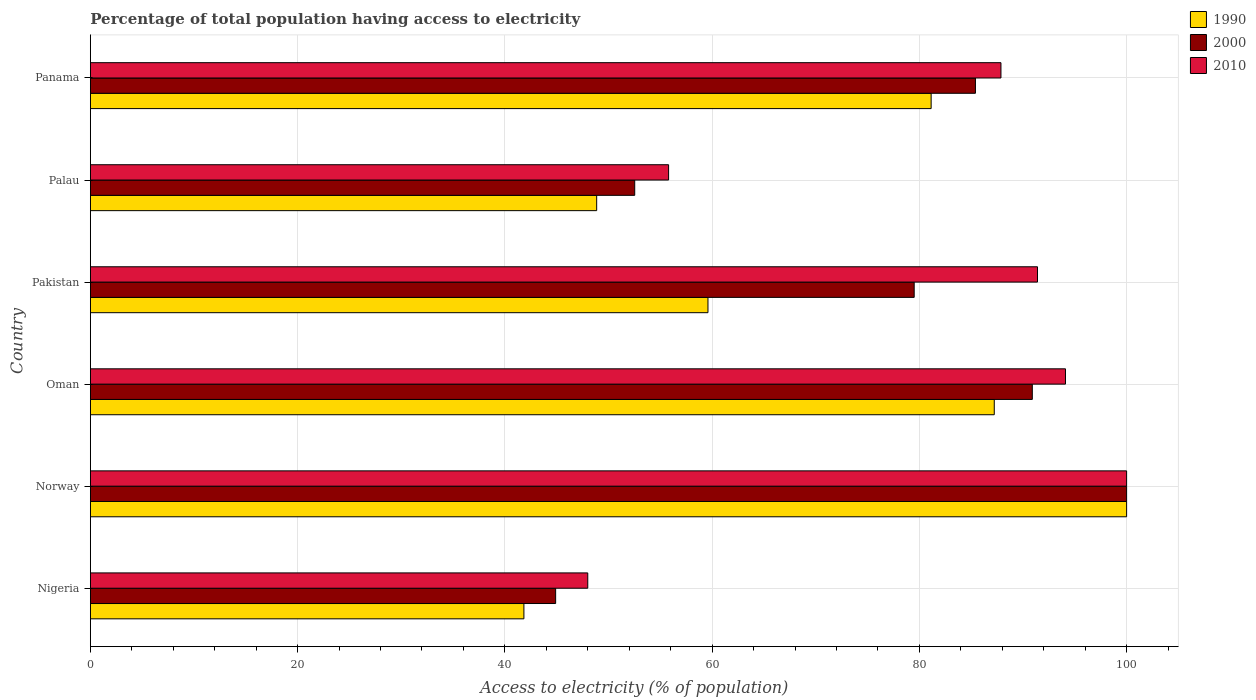How many groups of bars are there?
Give a very brief answer. 6. What is the label of the 5th group of bars from the top?
Your answer should be compact. Norway. What is the percentage of population that have access to electricity in 1990 in Panama?
Ensure brevity in your answer.  81.14. Across all countries, what is the maximum percentage of population that have access to electricity in 2000?
Make the answer very short. 100. Across all countries, what is the minimum percentage of population that have access to electricity in 2010?
Ensure brevity in your answer.  48. In which country was the percentage of population that have access to electricity in 2000 minimum?
Ensure brevity in your answer.  Nigeria. What is the total percentage of population that have access to electricity in 1990 in the graph?
Offer a terse response. 418.66. What is the difference between the percentage of population that have access to electricity in 1990 in Nigeria and that in Norway?
Offer a terse response. -58.16. What is the difference between the percentage of population that have access to electricity in 1990 in Panama and the percentage of population that have access to electricity in 2000 in Pakistan?
Your response must be concise. 1.64. What is the average percentage of population that have access to electricity in 1990 per country?
Your answer should be very brief. 69.78. What is the difference between the percentage of population that have access to electricity in 1990 and percentage of population that have access to electricity in 2010 in Nigeria?
Keep it short and to the point. -6.16. In how many countries, is the percentage of population that have access to electricity in 1990 greater than 96 %?
Make the answer very short. 1. What is the ratio of the percentage of population that have access to electricity in 2000 in Nigeria to that in Pakistan?
Provide a short and direct response. 0.56. Is the percentage of population that have access to electricity in 2000 in Nigeria less than that in Norway?
Ensure brevity in your answer.  Yes. What is the difference between the highest and the second highest percentage of population that have access to electricity in 1990?
Offer a very short reply. 12.77. In how many countries, is the percentage of population that have access to electricity in 2010 greater than the average percentage of population that have access to electricity in 2010 taken over all countries?
Your answer should be compact. 4. Is it the case that in every country, the sum of the percentage of population that have access to electricity in 2000 and percentage of population that have access to electricity in 1990 is greater than the percentage of population that have access to electricity in 2010?
Provide a succinct answer. Yes. How many bars are there?
Give a very brief answer. 18. What is the difference between two consecutive major ticks on the X-axis?
Provide a succinct answer. 20. Are the values on the major ticks of X-axis written in scientific E-notation?
Your answer should be very brief. No. Does the graph contain grids?
Provide a short and direct response. Yes. Where does the legend appear in the graph?
Ensure brevity in your answer.  Top right. How many legend labels are there?
Make the answer very short. 3. What is the title of the graph?
Provide a short and direct response. Percentage of total population having access to electricity. What is the label or title of the X-axis?
Provide a short and direct response. Access to electricity (% of population). What is the Access to electricity (% of population) in 1990 in Nigeria?
Your answer should be compact. 41.84. What is the Access to electricity (% of population) in 2000 in Nigeria?
Provide a short and direct response. 44.9. What is the Access to electricity (% of population) in 1990 in Norway?
Your response must be concise. 100. What is the Access to electricity (% of population) in 2010 in Norway?
Your answer should be compact. 100. What is the Access to electricity (% of population) of 1990 in Oman?
Your response must be concise. 87.23. What is the Access to electricity (% of population) in 2000 in Oman?
Your answer should be very brief. 90.9. What is the Access to electricity (% of population) of 2010 in Oman?
Make the answer very short. 94.1. What is the Access to electricity (% of population) of 1990 in Pakistan?
Ensure brevity in your answer.  59.6. What is the Access to electricity (% of population) of 2000 in Pakistan?
Provide a succinct answer. 79.5. What is the Access to electricity (% of population) of 2010 in Pakistan?
Provide a short and direct response. 91.4. What is the Access to electricity (% of population) in 1990 in Palau?
Give a very brief answer. 48.86. What is the Access to electricity (% of population) of 2000 in Palau?
Make the answer very short. 52.53. What is the Access to electricity (% of population) of 2010 in Palau?
Provide a short and direct response. 55.8. What is the Access to electricity (% of population) of 1990 in Panama?
Your response must be concise. 81.14. What is the Access to electricity (% of population) in 2000 in Panama?
Offer a terse response. 85.41. What is the Access to electricity (% of population) in 2010 in Panama?
Your answer should be very brief. 87.87. Across all countries, what is the maximum Access to electricity (% of population) of 1990?
Offer a terse response. 100. Across all countries, what is the maximum Access to electricity (% of population) of 2000?
Offer a very short reply. 100. Across all countries, what is the maximum Access to electricity (% of population) of 2010?
Ensure brevity in your answer.  100. Across all countries, what is the minimum Access to electricity (% of population) of 1990?
Offer a very short reply. 41.84. Across all countries, what is the minimum Access to electricity (% of population) in 2000?
Your answer should be very brief. 44.9. What is the total Access to electricity (% of population) of 1990 in the graph?
Keep it short and to the point. 418.66. What is the total Access to electricity (% of population) of 2000 in the graph?
Your response must be concise. 453.24. What is the total Access to electricity (% of population) of 2010 in the graph?
Provide a succinct answer. 477.17. What is the difference between the Access to electricity (% of population) in 1990 in Nigeria and that in Norway?
Keep it short and to the point. -58.16. What is the difference between the Access to electricity (% of population) in 2000 in Nigeria and that in Norway?
Provide a short and direct response. -55.1. What is the difference between the Access to electricity (% of population) of 2010 in Nigeria and that in Norway?
Keep it short and to the point. -52. What is the difference between the Access to electricity (% of population) in 1990 in Nigeria and that in Oman?
Offer a terse response. -45.39. What is the difference between the Access to electricity (% of population) in 2000 in Nigeria and that in Oman?
Make the answer very short. -46. What is the difference between the Access to electricity (% of population) in 2010 in Nigeria and that in Oman?
Provide a succinct answer. -46.1. What is the difference between the Access to electricity (% of population) of 1990 in Nigeria and that in Pakistan?
Keep it short and to the point. -17.76. What is the difference between the Access to electricity (% of population) of 2000 in Nigeria and that in Pakistan?
Your response must be concise. -34.6. What is the difference between the Access to electricity (% of population) of 2010 in Nigeria and that in Pakistan?
Provide a succinct answer. -43.4. What is the difference between the Access to electricity (% of population) of 1990 in Nigeria and that in Palau?
Your answer should be very brief. -7.02. What is the difference between the Access to electricity (% of population) of 2000 in Nigeria and that in Palau?
Your response must be concise. -7.63. What is the difference between the Access to electricity (% of population) in 2010 in Nigeria and that in Palau?
Keep it short and to the point. -7.8. What is the difference between the Access to electricity (% of population) of 1990 in Nigeria and that in Panama?
Offer a terse response. -39.3. What is the difference between the Access to electricity (% of population) of 2000 in Nigeria and that in Panama?
Give a very brief answer. -40.51. What is the difference between the Access to electricity (% of population) in 2010 in Nigeria and that in Panama?
Keep it short and to the point. -39.87. What is the difference between the Access to electricity (% of population) in 1990 in Norway and that in Oman?
Provide a succinct answer. 12.77. What is the difference between the Access to electricity (% of population) of 2000 in Norway and that in Oman?
Your answer should be compact. 9.1. What is the difference between the Access to electricity (% of population) of 2010 in Norway and that in Oman?
Keep it short and to the point. 5.9. What is the difference between the Access to electricity (% of population) of 1990 in Norway and that in Pakistan?
Ensure brevity in your answer.  40.4. What is the difference between the Access to electricity (% of population) of 2000 in Norway and that in Pakistan?
Provide a short and direct response. 20.5. What is the difference between the Access to electricity (% of population) in 2010 in Norway and that in Pakistan?
Provide a succinct answer. 8.6. What is the difference between the Access to electricity (% of population) of 1990 in Norway and that in Palau?
Provide a succinct answer. 51.14. What is the difference between the Access to electricity (% of population) of 2000 in Norway and that in Palau?
Make the answer very short. 47.47. What is the difference between the Access to electricity (% of population) of 2010 in Norway and that in Palau?
Keep it short and to the point. 44.2. What is the difference between the Access to electricity (% of population) in 1990 in Norway and that in Panama?
Provide a short and direct response. 18.86. What is the difference between the Access to electricity (% of population) in 2000 in Norway and that in Panama?
Give a very brief answer. 14.59. What is the difference between the Access to electricity (% of population) of 2010 in Norway and that in Panama?
Give a very brief answer. 12.13. What is the difference between the Access to electricity (% of population) in 1990 in Oman and that in Pakistan?
Your answer should be very brief. 27.63. What is the difference between the Access to electricity (% of population) of 2000 in Oman and that in Pakistan?
Provide a short and direct response. 11.4. What is the difference between the Access to electricity (% of population) in 2010 in Oman and that in Pakistan?
Make the answer very short. 2.7. What is the difference between the Access to electricity (% of population) of 1990 in Oman and that in Palau?
Provide a succinct answer. 38.37. What is the difference between the Access to electricity (% of population) in 2000 in Oman and that in Palau?
Your answer should be very brief. 38.37. What is the difference between the Access to electricity (% of population) in 2010 in Oman and that in Palau?
Provide a succinct answer. 38.3. What is the difference between the Access to electricity (% of population) of 1990 in Oman and that in Panama?
Make the answer very short. 6.09. What is the difference between the Access to electricity (% of population) of 2000 in Oman and that in Panama?
Offer a terse response. 5.49. What is the difference between the Access to electricity (% of population) in 2010 in Oman and that in Panama?
Keep it short and to the point. 6.23. What is the difference between the Access to electricity (% of population) of 1990 in Pakistan and that in Palau?
Ensure brevity in your answer.  10.74. What is the difference between the Access to electricity (% of population) in 2000 in Pakistan and that in Palau?
Offer a terse response. 26.97. What is the difference between the Access to electricity (% of population) in 2010 in Pakistan and that in Palau?
Make the answer very short. 35.6. What is the difference between the Access to electricity (% of population) in 1990 in Pakistan and that in Panama?
Give a very brief answer. -21.54. What is the difference between the Access to electricity (% of population) in 2000 in Pakistan and that in Panama?
Your answer should be compact. -5.91. What is the difference between the Access to electricity (% of population) in 2010 in Pakistan and that in Panama?
Offer a terse response. 3.53. What is the difference between the Access to electricity (% of population) of 1990 in Palau and that in Panama?
Your response must be concise. -32.28. What is the difference between the Access to electricity (% of population) of 2000 in Palau and that in Panama?
Your answer should be very brief. -32.88. What is the difference between the Access to electricity (% of population) of 2010 in Palau and that in Panama?
Provide a short and direct response. -32.07. What is the difference between the Access to electricity (% of population) in 1990 in Nigeria and the Access to electricity (% of population) in 2000 in Norway?
Your answer should be very brief. -58.16. What is the difference between the Access to electricity (% of population) of 1990 in Nigeria and the Access to electricity (% of population) of 2010 in Norway?
Your response must be concise. -58.16. What is the difference between the Access to electricity (% of population) in 2000 in Nigeria and the Access to electricity (% of population) in 2010 in Norway?
Ensure brevity in your answer.  -55.1. What is the difference between the Access to electricity (% of population) of 1990 in Nigeria and the Access to electricity (% of population) of 2000 in Oman?
Make the answer very short. -49.06. What is the difference between the Access to electricity (% of population) in 1990 in Nigeria and the Access to electricity (% of population) in 2010 in Oman?
Provide a succinct answer. -52.26. What is the difference between the Access to electricity (% of population) of 2000 in Nigeria and the Access to electricity (% of population) of 2010 in Oman?
Keep it short and to the point. -49.2. What is the difference between the Access to electricity (% of population) in 1990 in Nigeria and the Access to electricity (% of population) in 2000 in Pakistan?
Make the answer very short. -37.66. What is the difference between the Access to electricity (% of population) of 1990 in Nigeria and the Access to electricity (% of population) of 2010 in Pakistan?
Keep it short and to the point. -49.56. What is the difference between the Access to electricity (% of population) in 2000 in Nigeria and the Access to electricity (% of population) in 2010 in Pakistan?
Offer a terse response. -46.5. What is the difference between the Access to electricity (% of population) in 1990 in Nigeria and the Access to electricity (% of population) in 2000 in Palau?
Offer a very short reply. -10.69. What is the difference between the Access to electricity (% of population) in 1990 in Nigeria and the Access to electricity (% of population) in 2010 in Palau?
Your answer should be compact. -13.96. What is the difference between the Access to electricity (% of population) in 1990 in Nigeria and the Access to electricity (% of population) in 2000 in Panama?
Make the answer very short. -43.57. What is the difference between the Access to electricity (% of population) in 1990 in Nigeria and the Access to electricity (% of population) in 2010 in Panama?
Give a very brief answer. -46.04. What is the difference between the Access to electricity (% of population) of 2000 in Nigeria and the Access to electricity (% of population) of 2010 in Panama?
Make the answer very short. -42.97. What is the difference between the Access to electricity (% of population) in 1990 in Norway and the Access to electricity (% of population) in 2000 in Oman?
Offer a very short reply. 9.1. What is the difference between the Access to electricity (% of population) of 1990 in Norway and the Access to electricity (% of population) of 2010 in Oman?
Ensure brevity in your answer.  5.9. What is the difference between the Access to electricity (% of population) in 1990 in Norway and the Access to electricity (% of population) in 2000 in Pakistan?
Make the answer very short. 20.5. What is the difference between the Access to electricity (% of population) of 2000 in Norway and the Access to electricity (% of population) of 2010 in Pakistan?
Make the answer very short. 8.6. What is the difference between the Access to electricity (% of population) in 1990 in Norway and the Access to electricity (% of population) in 2000 in Palau?
Ensure brevity in your answer.  47.47. What is the difference between the Access to electricity (% of population) in 1990 in Norway and the Access to electricity (% of population) in 2010 in Palau?
Offer a very short reply. 44.2. What is the difference between the Access to electricity (% of population) in 2000 in Norway and the Access to electricity (% of population) in 2010 in Palau?
Your answer should be very brief. 44.2. What is the difference between the Access to electricity (% of population) in 1990 in Norway and the Access to electricity (% of population) in 2000 in Panama?
Provide a short and direct response. 14.59. What is the difference between the Access to electricity (% of population) of 1990 in Norway and the Access to electricity (% of population) of 2010 in Panama?
Offer a terse response. 12.13. What is the difference between the Access to electricity (% of population) of 2000 in Norway and the Access to electricity (% of population) of 2010 in Panama?
Ensure brevity in your answer.  12.13. What is the difference between the Access to electricity (% of population) in 1990 in Oman and the Access to electricity (% of population) in 2000 in Pakistan?
Your response must be concise. 7.73. What is the difference between the Access to electricity (% of population) in 1990 in Oman and the Access to electricity (% of population) in 2010 in Pakistan?
Ensure brevity in your answer.  -4.17. What is the difference between the Access to electricity (% of population) in 2000 in Oman and the Access to electricity (% of population) in 2010 in Pakistan?
Offer a terse response. -0.5. What is the difference between the Access to electricity (% of population) of 1990 in Oman and the Access to electricity (% of population) of 2000 in Palau?
Your answer should be compact. 34.7. What is the difference between the Access to electricity (% of population) of 1990 in Oman and the Access to electricity (% of population) of 2010 in Palau?
Provide a short and direct response. 31.43. What is the difference between the Access to electricity (% of population) of 2000 in Oman and the Access to electricity (% of population) of 2010 in Palau?
Your answer should be very brief. 35.1. What is the difference between the Access to electricity (% of population) of 1990 in Oman and the Access to electricity (% of population) of 2000 in Panama?
Ensure brevity in your answer.  1.82. What is the difference between the Access to electricity (% of population) of 1990 in Oman and the Access to electricity (% of population) of 2010 in Panama?
Your answer should be compact. -0.65. What is the difference between the Access to electricity (% of population) in 2000 in Oman and the Access to electricity (% of population) in 2010 in Panama?
Keep it short and to the point. 3.03. What is the difference between the Access to electricity (% of population) in 1990 in Pakistan and the Access to electricity (% of population) in 2000 in Palau?
Keep it short and to the point. 7.07. What is the difference between the Access to electricity (% of population) in 2000 in Pakistan and the Access to electricity (% of population) in 2010 in Palau?
Offer a very short reply. 23.7. What is the difference between the Access to electricity (% of population) of 1990 in Pakistan and the Access to electricity (% of population) of 2000 in Panama?
Provide a short and direct response. -25.81. What is the difference between the Access to electricity (% of population) in 1990 in Pakistan and the Access to electricity (% of population) in 2010 in Panama?
Your response must be concise. -28.27. What is the difference between the Access to electricity (% of population) of 2000 in Pakistan and the Access to electricity (% of population) of 2010 in Panama?
Offer a very short reply. -8.37. What is the difference between the Access to electricity (% of population) of 1990 in Palau and the Access to electricity (% of population) of 2000 in Panama?
Your answer should be compact. -36.55. What is the difference between the Access to electricity (% of population) in 1990 in Palau and the Access to electricity (% of population) in 2010 in Panama?
Provide a short and direct response. -39.01. What is the difference between the Access to electricity (% of population) of 2000 in Palau and the Access to electricity (% of population) of 2010 in Panama?
Make the answer very short. -35.34. What is the average Access to electricity (% of population) in 1990 per country?
Your answer should be very brief. 69.78. What is the average Access to electricity (% of population) in 2000 per country?
Offer a terse response. 75.54. What is the average Access to electricity (% of population) of 2010 per country?
Your answer should be very brief. 79.53. What is the difference between the Access to electricity (% of population) of 1990 and Access to electricity (% of population) of 2000 in Nigeria?
Give a very brief answer. -3.06. What is the difference between the Access to electricity (% of population) of 1990 and Access to electricity (% of population) of 2010 in Nigeria?
Keep it short and to the point. -6.16. What is the difference between the Access to electricity (% of population) in 2000 and Access to electricity (% of population) in 2010 in Nigeria?
Your answer should be compact. -3.1. What is the difference between the Access to electricity (% of population) in 1990 and Access to electricity (% of population) in 2000 in Norway?
Provide a succinct answer. 0. What is the difference between the Access to electricity (% of population) of 2000 and Access to electricity (% of population) of 2010 in Norway?
Ensure brevity in your answer.  0. What is the difference between the Access to electricity (% of population) of 1990 and Access to electricity (% of population) of 2000 in Oman?
Your answer should be compact. -3.67. What is the difference between the Access to electricity (% of population) in 1990 and Access to electricity (% of population) in 2010 in Oman?
Offer a terse response. -6.87. What is the difference between the Access to electricity (% of population) in 2000 and Access to electricity (% of population) in 2010 in Oman?
Provide a short and direct response. -3.2. What is the difference between the Access to electricity (% of population) of 1990 and Access to electricity (% of population) of 2000 in Pakistan?
Make the answer very short. -19.9. What is the difference between the Access to electricity (% of population) in 1990 and Access to electricity (% of population) in 2010 in Pakistan?
Offer a terse response. -31.8. What is the difference between the Access to electricity (% of population) in 2000 and Access to electricity (% of population) in 2010 in Pakistan?
Offer a very short reply. -11.9. What is the difference between the Access to electricity (% of population) of 1990 and Access to electricity (% of population) of 2000 in Palau?
Give a very brief answer. -3.67. What is the difference between the Access to electricity (% of population) in 1990 and Access to electricity (% of population) in 2010 in Palau?
Provide a short and direct response. -6.94. What is the difference between the Access to electricity (% of population) in 2000 and Access to electricity (% of population) in 2010 in Palau?
Offer a terse response. -3.27. What is the difference between the Access to electricity (% of population) in 1990 and Access to electricity (% of population) in 2000 in Panama?
Your response must be concise. -4.28. What is the difference between the Access to electricity (% of population) of 1990 and Access to electricity (% of population) of 2010 in Panama?
Keep it short and to the point. -6.74. What is the difference between the Access to electricity (% of population) in 2000 and Access to electricity (% of population) in 2010 in Panama?
Provide a short and direct response. -2.46. What is the ratio of the Access to electricity (% of population) in 1990 in Nigeria to that in Norway?
Your answer should be compact. 0.42. What is the ratio of the Access to electricity (% of population) in 2000 in Nigeria to that in Norway?
Ensure brevity in your answer.  0.45. What is the ratio of the Access to electricity (% of population) in 2010 in Nigeria to that in Norway?
Ensure brevity in your answer.  0.48. What is the ratio of the Access to electricity (% of population) of 1990 in Nigeria to that in Oman?
Give a very brief answer. 0.48. What is the ratio of the Access to electricity (% of population) of 2000 in Nigeria to that in Oman?
Ensure brevity in your answer.  0.49. What is the ratio of the Access to electricity (% of population) in 2010 in Nigeria to that in Oman?
Your answer should be very brief. 0.51. What is the ratio of the Access to electricity (% of population) in 1990 in Nigeria to that in Pakistan?
Provide a succinct answer. 0.7. What is the ratio of the Access to electricity (% of population) of 2000 in Nigeria to that in Pakistan?
Provide a succinct answer. 0.56. What is the ratio of the Access to electricity (% of population) of 2010 in Nigeria to that in Pakistan?
Your response must be concise. 0.53. What is the ratio of the Access to electricity (% of population) of 1990 in Nigeria to that in Palau?
Ensure brevity in your answer.  0.86. What is the ratio of the Access to electricity (% of population) in 2000 in Nigeria to that in Palau?
Your answer should be very brief. 0.85. What is the ratio of the Access to electricity (% of population) of 2010 in Nigeria to that in Palau?
Give a very brief answer. 0.86. What is the ratio of the Access to electricity (% of population) in 1990 in Nigeria to that in Panama?
Keep it short and to the point. 0.52. What is the ratio of the Access to electricity (% of population) of 2000 in Nigeria to that in Panama?
Provide a succinct answer. 0.53. What is the ratio of the Access to electricity (% of population) of 2010 in Nigeria to that in Panama?
Offer a terse response. 0.55. What is the ratio of the Access to electricity (% of population) in 1990 in Norway to that in Oman?
Keep it short and to the point. 1.15. What is the ratio of the Access to electricity (% of population) of 2000 in Norway to that in Oman?
Offer a very short reply. 1.1. What is the ratio of the Access to electricity (% of population) of 2010 in Norway to that in Oman?
Keep it short and to the point. 1.06. What is the ratio of the Access to electricity (% of population) in 1990 in Norway to that in Pakistan?
Your answer should be very brief. 1.68. What is the ratio of the Access to electricity (% of population) in 2000 in Norway to that in Pakistan?
Offer a terse response. 1.26. What is the ratio of the Access to electricity (% of population) in 2010 in Norway to that in Pakistan?
Ensure brevity in your answer.  1.09. What is the ratio of the Access to electricity (% of population) in 1990 in Norway to that in Palau?
Offer a terse response. 2.05. What is the ratio of the Access to electricity (% of population) of 2000 in Norway to that in Palau?
Your answer should be compact. 1.9. What is the ratio of the Access to electricity (% of population) in 2010 in Norway to that in Palau?
Offer a terse response. 1.79. What is the ratio of the Access to electricity (% of population) in 1990 in Norway to that in Panama?
Make the answer very short. 1.23. What is the ratio of the Access to electricity (% of population) of 2000 in Norway to that in Panama?
Your answer should be very brief. 1.17. What is the ratio of the Access to electricity (% of population) of 2010 in Norway to that in Panama?
Ensure brevity in your answer.  1.14. What is the ratio of the Access to electricity (% of population) in 1990 in Oman to that in Pakistan?
Your response must be concise. 1.46. What is the ratio of the Access to electricity (% of population) in 2000 in Oman to that in Pakistan?
Provide a succinct answer. 1.14. What is the ratio of the Access to electricity (% of population) of 2010 in Oman to that in Pakistan?
Offer a very short reply. 1.03. What is the ratio of the Access to electricity (% of population) of 1990 in Oman to that in Palau?
Your answer should be very brief. 1.79. What is the ratio of the Access to electricity (% of population) in 2000 in Oman to that in Palau?
Offer a terse response. 1.73. What is the ratio of the Access to electricity (% of population) in 2010 in Oman to that in Palau?
Give a very brief answer. 1.69. What is the ratio of the Access to electricity (% of population) in 1990 in Oman to that in Panama?
Ensure brevity in your answer.  1.08. What is the ratio of the Access to electricity (% of population) of 2000 in Oman to that in Panama?
Provide a short and direct response. 1.06. What is the ratio of the Access to electricity (% of population) in 2010 in Oman to that in Panama?
Offer a very short reply. 1.07. What is the ratio of the Access to electricity (% of population) of 1990 in Pakistan to that in Palau?
Offer a terse response. 1.22. What is the ratio of the Access to electricity (% of population) in 2000 in Pakistan to that in Palau?
Keep it short and to the point. 1.51. What is the ratio of the Access to electricity (% of population) in 2010 in Pakistan to that in Palau?
Offer a terse response. 1.64. What is the ratio of the Access to electricity (% of population) of 1990 in Pakistan to that in Panama?
Your answer should be very brief. 0.73. What is the ratio of the Access to electricity (% of population) of 2000 in Pakistan to that in Panama?
Your answer should be compact. 0.93. What is the ratio of the Access to electricity (% of population) of 2010 in Pakistan to that in Panama?
Ensure brevity in your answer.  1.04. What is the ratio of the Access to electricity (% of population) of 1990 in Palau to that in Panama?
Your answer should be very brief. 0.6. What is the ratio of the Access to electricity (% of population) in 2000 in Palau to that in Panama?
Your response must be concise. 0.61. What is the ratio of the Access to electricity (% of population) of 2010 in Palau to that in Panama?
Ensure brevity in your answer.  0.64. What is the difference between the highest and the second highest Access to electricity (% of population) in 1990?
Provide a short and direct response. 12.77. What is the difference between the highest and the second highest Access to electricity (% of population) of 2000?
Offer a terse response. 9.1. What is the difference between the highest and the second highest Access to electricity (% of population) of 2010?
Your response must be concise. 5.9. What is the difference between the highest and the lowest Access to electricity (% of population) in 1990?
Ensure brevity in your answer.  58.16. What is the difference between the highest and the lowest Access to electricity (% of population) of 2000?
Offer a terse response. 55.1. 